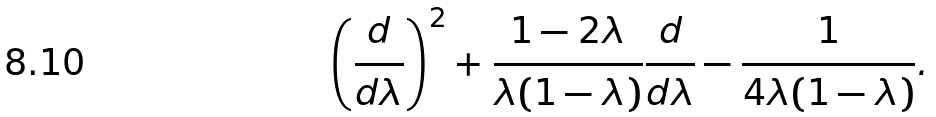<formula> <loc_0><loc_0><loc_500><loc_500>\left ( \frac { d } { d \lambda } \right ) ^ { 2 } + \frac { 1 - 2 \lambda } { \lambda ( 1 - \lambda ) } \frac { d } { d \lambda } - \frac { 1 } { 4 \lambda ( 1 - \lambda ) } .</formula> 